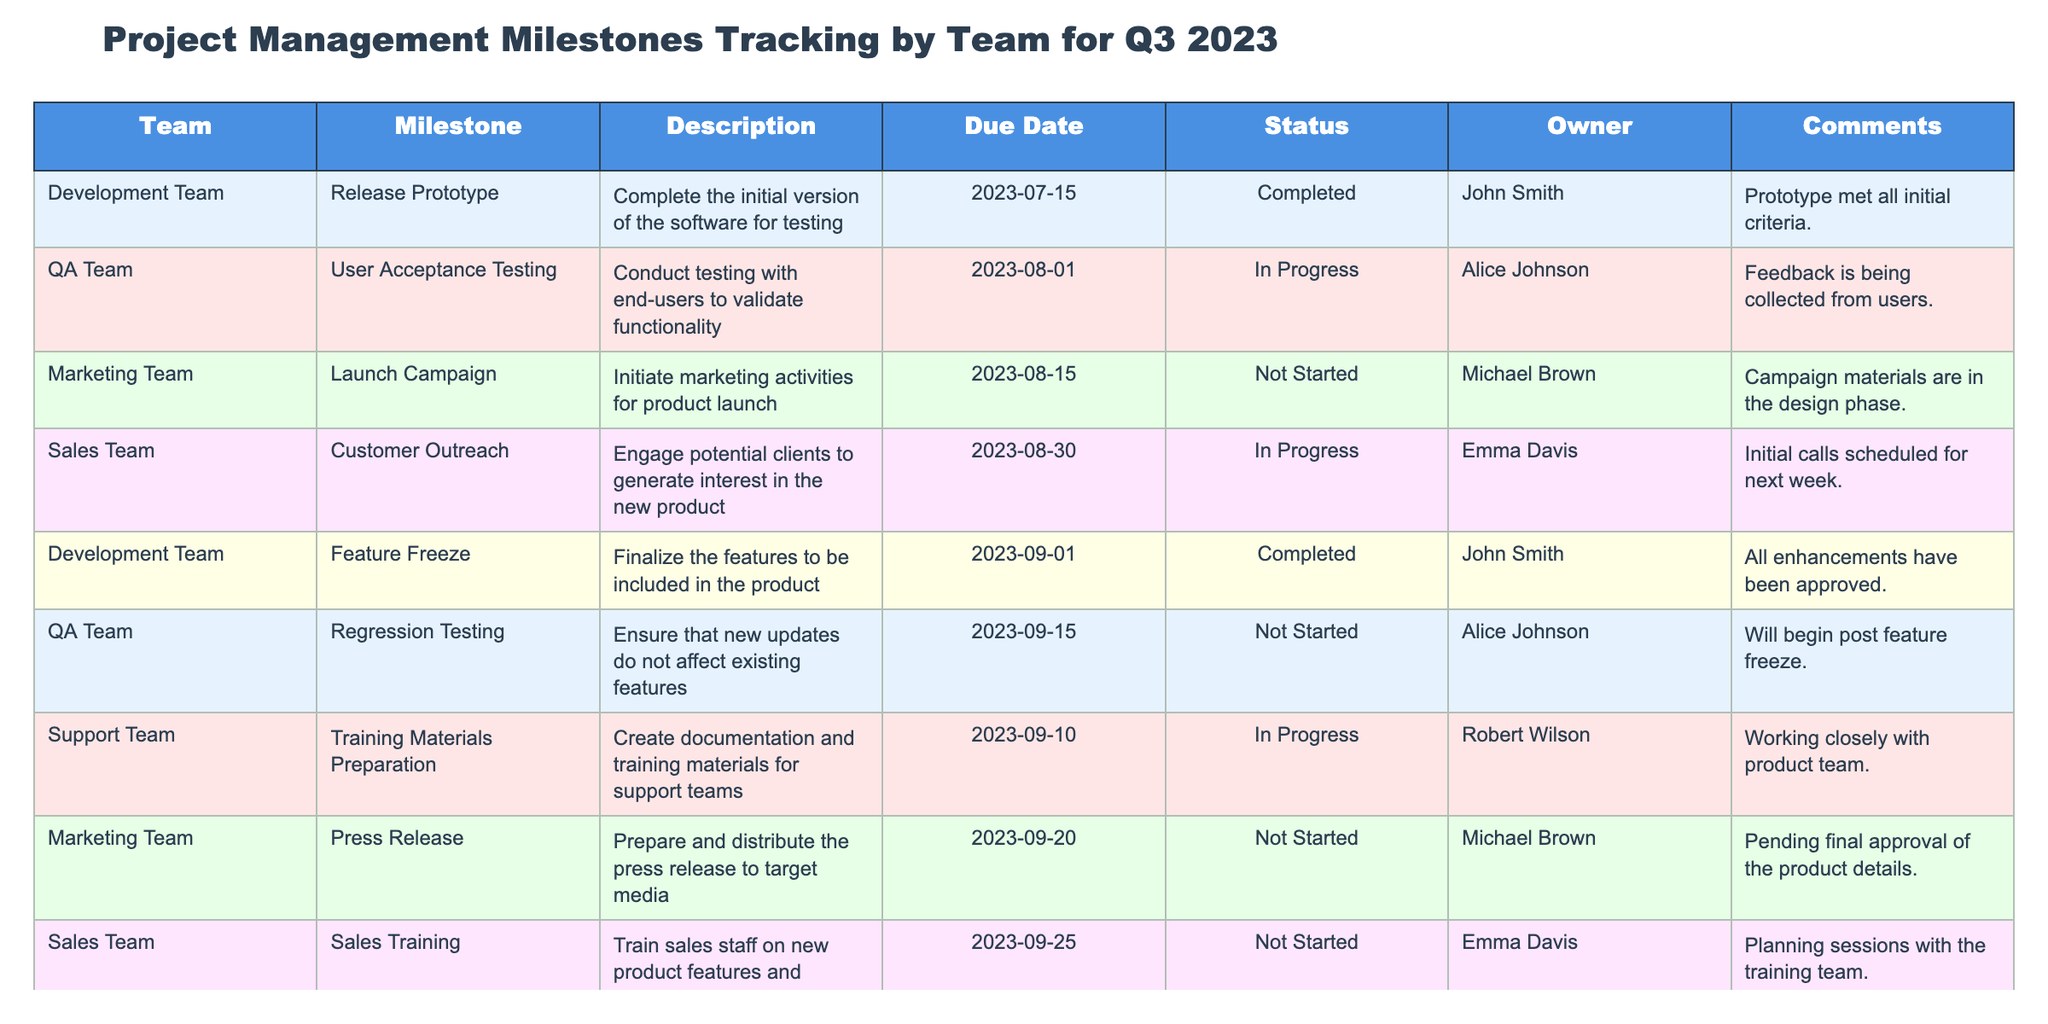What is the status of the "Final Release" milestone? The table shows that the "Final Release" milestone is marked as "Not Started."
Answer: Not Started Who is the owner of the "Press Release" milestone? The "Press Release" milestone is assigned to Michael Brown according to the Owner column.
Answer: Michael Brown What is the due date for the "User Acceptance Testing" milestone? The due date listed for "User Acceptance Testing" is 2023-08-01, as seen in the corresponding row of the table.
Answer: 2023-08-01 How many milestones are marked as "Not Started"? By reviewing the Status column, I find three milestones: "Launch Campaign," "Press Release," and "Sales Training" are listed as "Not Started."
Answer: 3 Which team has completed their milestones? The Development Team has two completed milestones: "Release Prototype" and "Feature Freeze."
Answer: Development Team Is there any comment associated with the "Customer Outreach" milestone? Yes, there is a comment: "Initial calls scheduled for next week," as indicated in the Comments column of the table.
Answer: Yes What are the milestones due on or before September 15, 2023? Checking the Due Date column, the milestones due on or before September 15, 2023, are "Release Prototype," "User Acceptance Testing," and "Regression Testing."
Answer: 3 Which team has the milestone with the nearest due date? The "User Acceptance Testing" milestone from the QA Team has the nearest due date of 2023-08-01.
Answer: QA Team What is the difference in the number of "Completed" milestones and "Not Started" milestones? There are 2 completed milestones and 3 not started milestones, making a difference of 1 when subtracting the two counts (3 - 2 = 1).
Answer: 1 List the milestones owned by Alice Johnson. Alice Johnson owns two milestones: "User Acceptance Testing" and "Regression Testing," as seen in the table.
Answer: 2 On which milestone does the Development Team depend on QA completion? The Development Team's "Final Release" milestone is dependent on QA completion, as noted in the Comments column.
Answer: Final Release How many teams have milestones that are currently in progress? The teams with milestones in progress are the QA Team, Support Team, and Sales Team, totaling three teams.
Answer: 3 Is the "Sales Training" milestone due before the "Feature Freeze"? No, the "Sales Training" milestone is due on 2023-09-25, which is after the "Feature Freeze" due on 2023-09-01.
Answer: No 